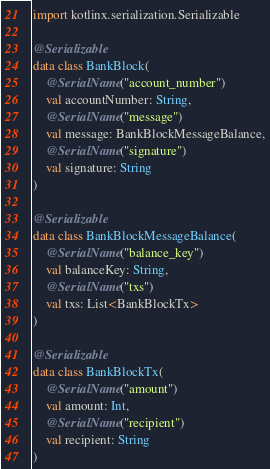Convert code to text. <code><loc_0><loc_0><loc_500><loc_500><_Kotlin_>import kotlinx.serialization.Serializable

@Serializable
data class BankBlock(
    @SerialName("account_number")
    val accountNumber: String,
    @SerialName("message")
    val message: BankBlockMessageBalance,
    @SerialName("signature")
    val signature: String
)

@Serializable
data class BankBlockMessageBalance(
    @SerialName("balance_key")
    val balanceKey: String,
    @SerialName("txs")
    val txs: List<BankBlockTx>
)

@Serializable
data class BankBlockTx(
    @SerialName("amount")
    val amount: Int,
    @SerialName("recipient")
    val recipient: String
)
</code> 